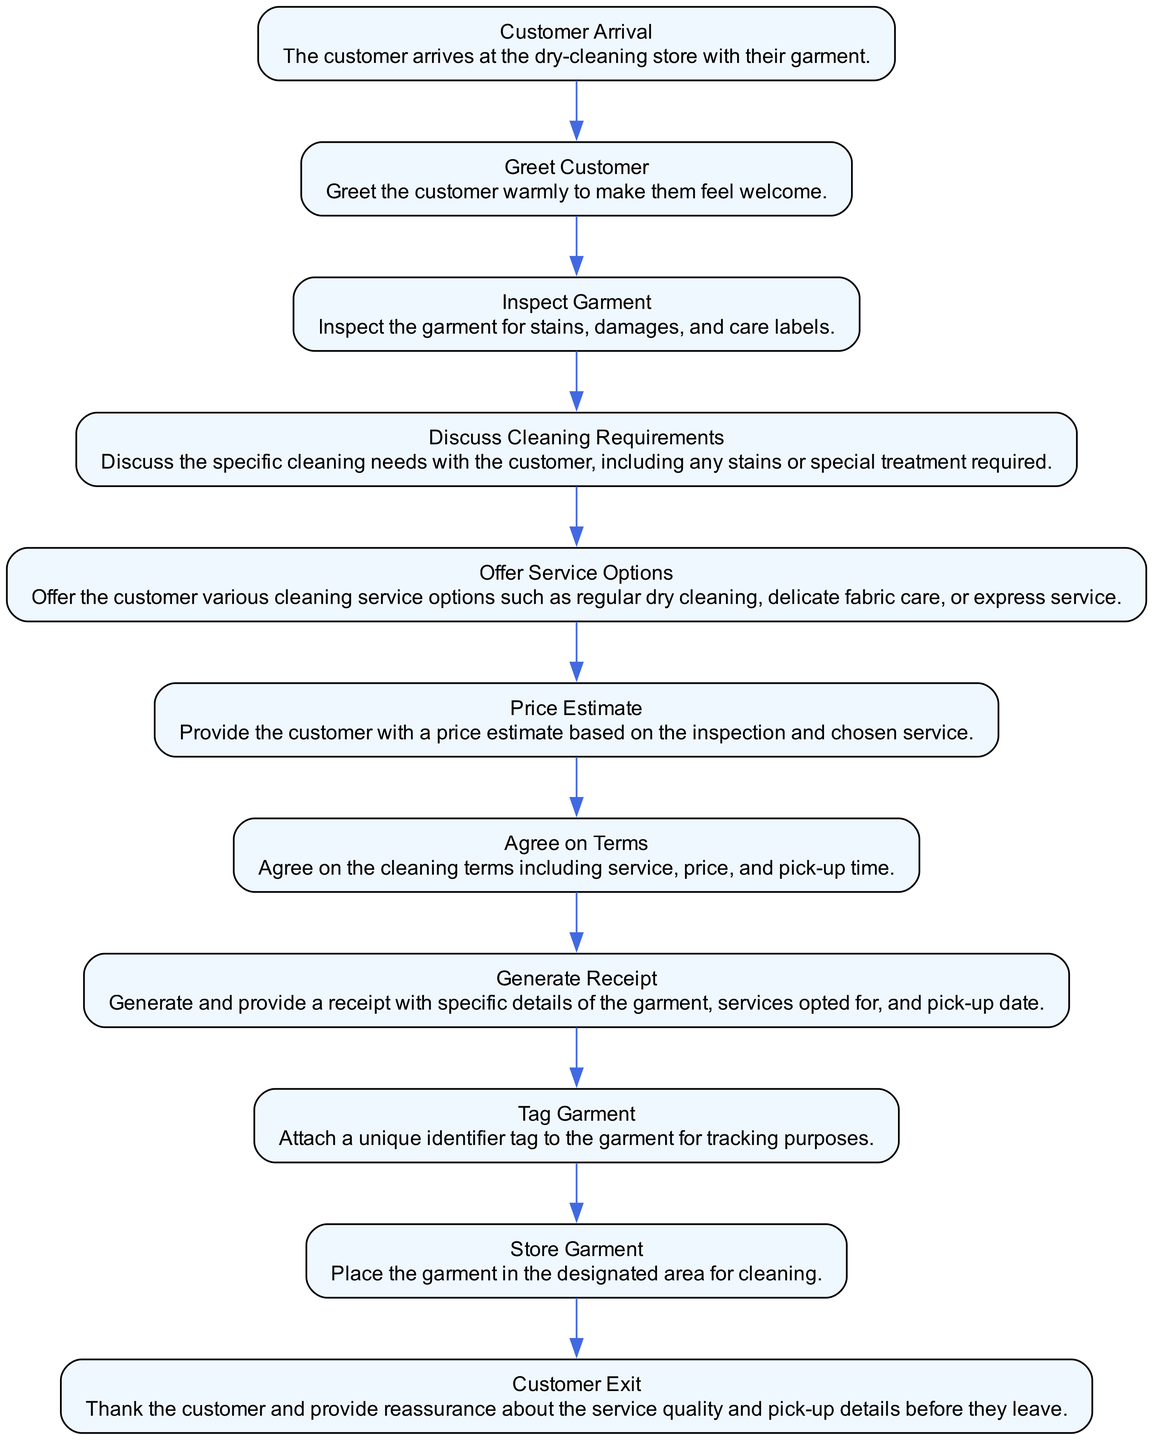What is the first step once the customer arrives? The first step is "Customer Arrival," which indicates the start of the process when the customer comes into the store with their garment.
Answer: Customer Arrival How many main steps are in the flow chart? The flow chart consists of 11 steps in total, reflecting the complete process of garment drop-off and service selection.
Answer: 11 What happens after inspecting the garment? After "Inspect Garment," the next step is "Discuss Cleaning Requirements," where the customer’s specific cleaning needs are discussed.
Answer: Discuss Cleaning Requirements Which node follows "Agree on Terms"? The node that follows "Agree on Terms" is "Generate Receipt," marking the transition to providing the customer with a receipt for their service agreement.
Answer: Generate Receipt What is the purpose of the tag garment step? The purpose of the "Tag Garment" step is to attach a unique identifier to the garment for tracking purposes during the cleaning process.
Answer: To attach a unique identifier for tracking What action takes place before the customer exits the store? Before the customer exits, the last action is "Customer Exit," which includes thanking the customer and providing reassurance about the service quality and pick-up details.
Answer: Customer Exit What is the last step in the process? The last step in the process is "Customer Exit," indicating the conclusion of the garment drop-off and cleaning service agreement.
Answer: Customer Exit What is the relationship between "Offer Service Options" and "Price Estimate"? "Offer Service Options" occurs before "Price Estimate," as the price is provided after discussing the available service options with the customer.
Answer: Offer Service Options → Price Estimate What does the process start with? The process starts with the "Customer Arrival," which is the initiation of the entire garment drop-off procedure.
Answer: Customer Arrival How do we ensure the tracking of garments? Tracking of garments is ensured through the "Tag Garment" step, where each garment receives a unique identifier tag.
Answer: By tagging the garment with a unique identifier 